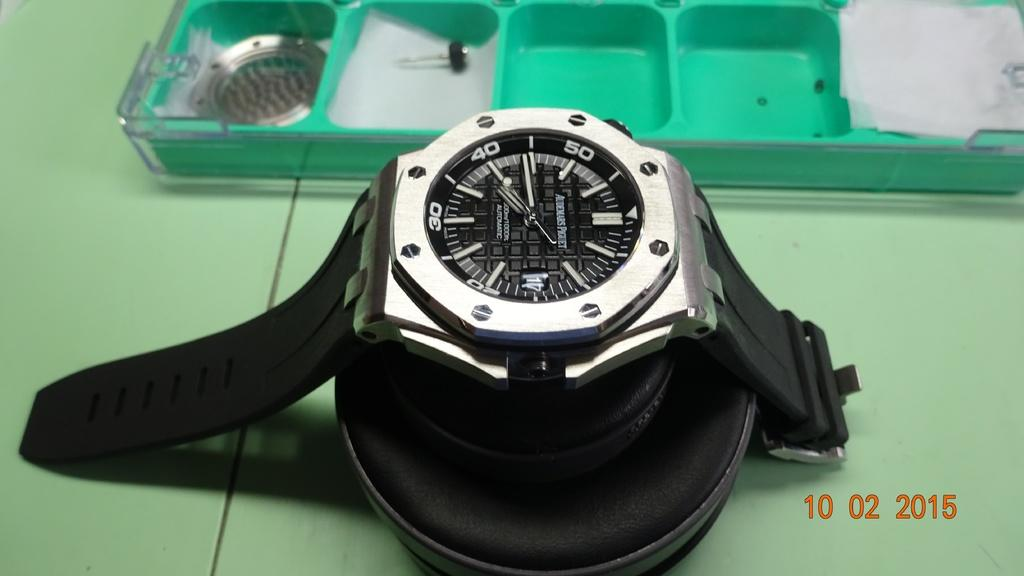<image>
Give a short and clear explanation of the subsequent image. Black and silver watch which has the hand on the number 40. 